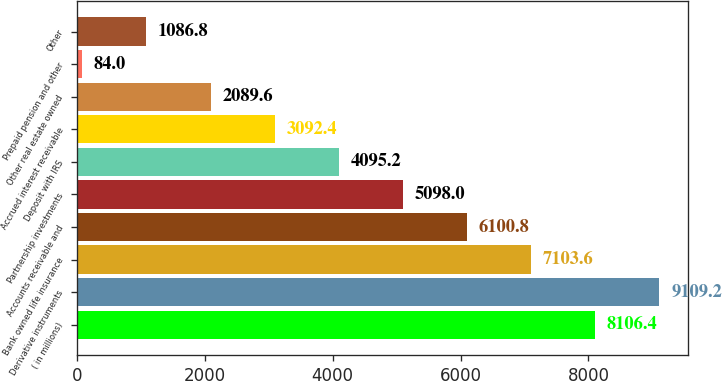Convert chart. <chart><loc_0><loc_0><loc_500><loc_500><bar_chart><fcel>( in millions)<fcel>Derivative instruments<fcel>Bank owned life insurance<fcel>Accounts receivable and<fcel>Partnership investments<fcel>Deposit with IRS<fcel>Accrued interest receivable<fcel>Other real estate owned<fcel>Prepaid pension and other<fcel>Other<nl><fcel>8106.4<fcel>9109.2<fcel>7103.6<fcel>6100.8<fcel>5098<fcel>4095.2<fcel>3092.4<fcel>2089.6<fcel>84<fcel>1086.8<nl></chart> 